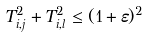Convert formula to latex. <formula><loc_0><loc_0><loc_500><loc_500>T _ { i , j } ^ { 2 } + T _ { i , l } ^ { 2 } \leq ( 1 + \varepsilon ) ^ { 2 }</formula> 